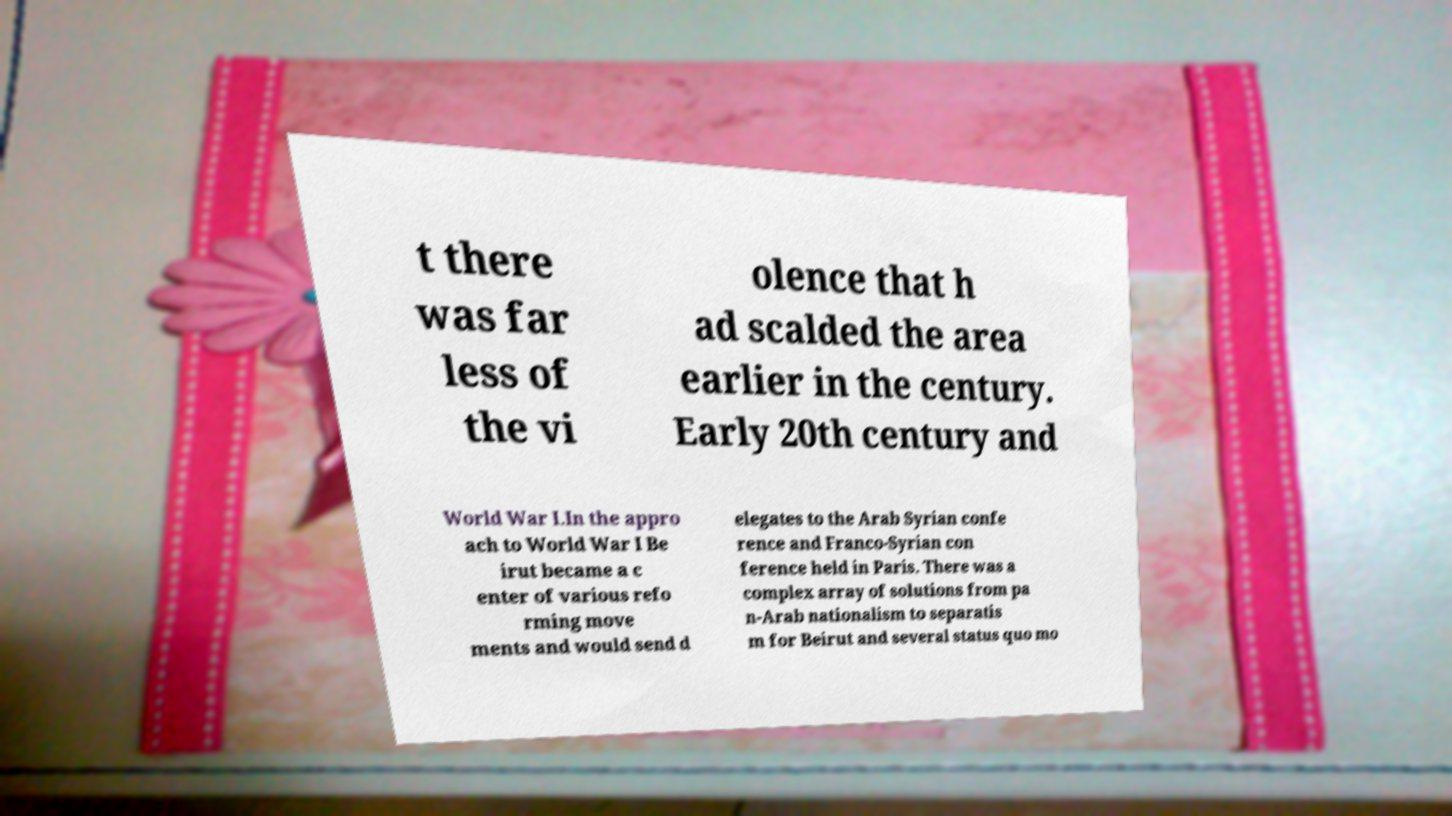For documentation purposes, I need the text within this image transcribed. Could you provide that? t there was far less of the vi olence that h ad scalded the area earlier in the century. Early 20th century and World War I.In the appro ach to World War I Be irut became a c enter of various refo rming move ments and would send d elegates to the Arab Syrian confe rence and Franco-Syrian con ference held in Paris. There was a complex array of solutions from pa n-Arab nationalism to separatis m for Beirut and several status quo mo 